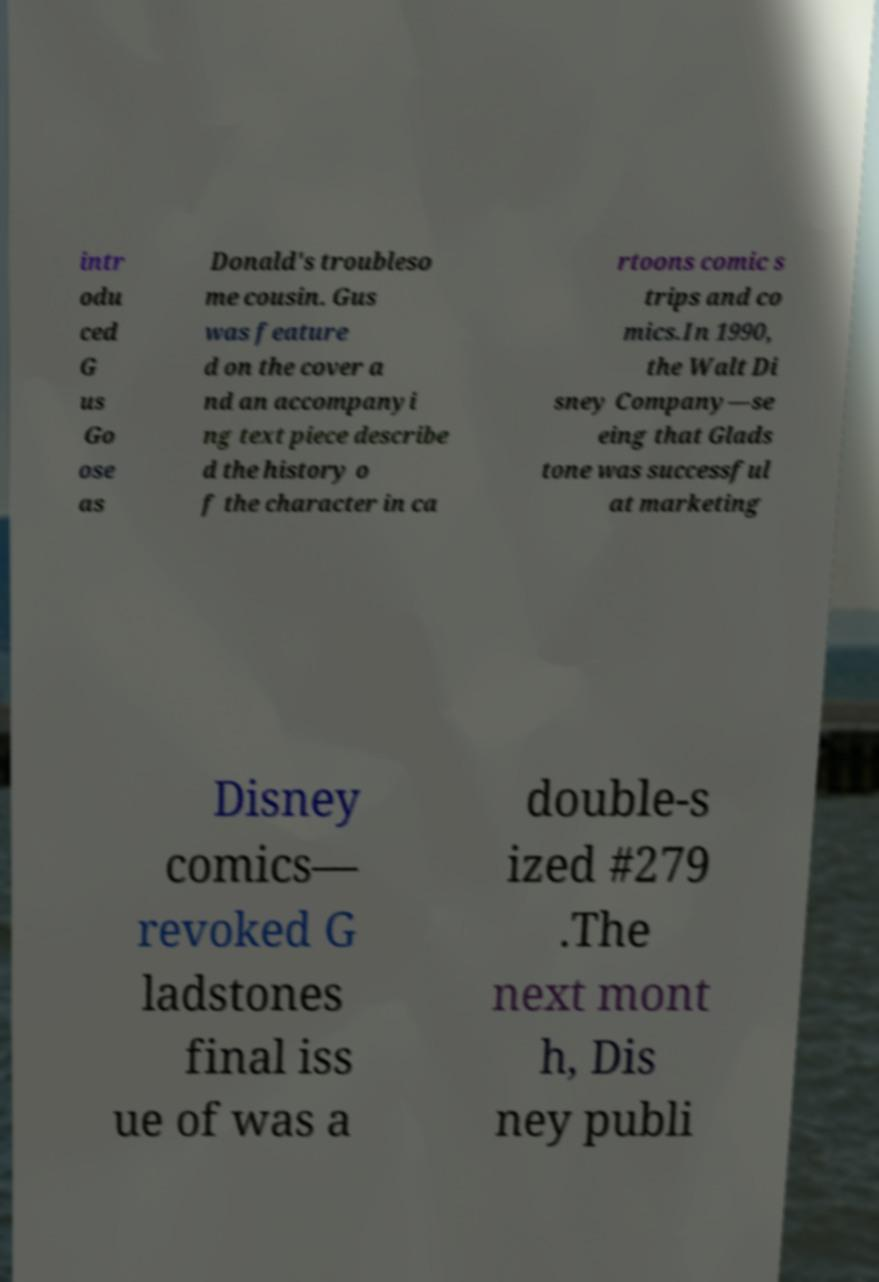Could you extract and type out the text from this image? intr odu ced G us Go ose as Donald's troubleso me cousin. Gus was feature d on the cover a nd an accompanyi ng text piece describe d the history o f the character in ca rtoons comic s trips and co mics.In 1990, the Walt Di sney Company—se eing that Glads tone was successful at marketing Disney comics— revoked G ladstones final iss ue of was a double-s ized #279 .The next mont h, Dis ney publi 